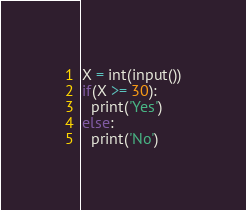<code> <loc_0><loc_0><loc_500><loc_500><_Python_>X = int(input())
if(X >= 30):
  print('Yes')
else:
  print('No')</code> 